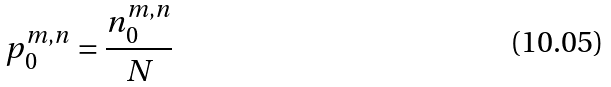<formula> <loc_0><loc_0><loc_500><loc_500>p _ { 0 } ^ { m , n } = \frac { n _ { 0 } ^ { m , n } } { N }</formula> 